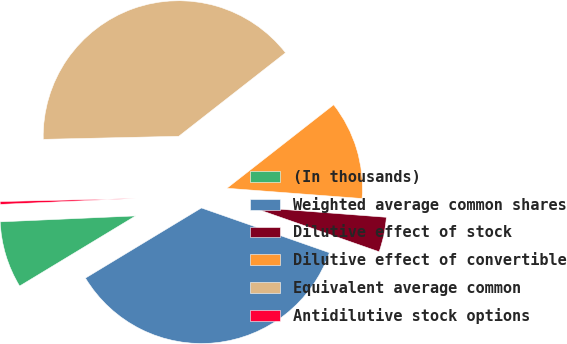Convert chart. <chart><loc_0><loc_0><loc_500><loc_500><pie_chart><fcel>(In thousands)<fcel>Weighted average common shares<fcel>Dilutive effect of stock<fcel>Dilutive effect of convertible<fcel>Equivalent average common<fcel>Antidilutive stock options<nl><fcel>7.96%<fcel>35.98%<fcel>4.15%<fcel>11.77%<fcel>39.79%<fcel>0.34%<nl></chart> 